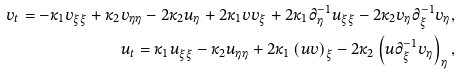<formula> <loc_0><loc_0><loc_500><loc_500>v _ { t } = - \kappa _ { 1 } v _ { \xi \xi } + \kappa _ { 2 } v _ { \eta \eta } - 2 \kappa _ { 2 } u _ { \eta } + 2 \kappa _ { 1 } v v _ { \xi } + 2 \kappa _ { 1 } \partial _ { \eta } ^ { - 1 } u _ { \xi \xi } - 2 \kappa _ { 2 } v _ { \eta } \partial _ { \xi } ^ { - 1 } v _ { \eta } , \\ u _ { t } = \kappa _ { 1 } u _ { \xi \xi } - \kappa _ { 2 } u _ { \eta \eta } + 2 \kappa _ { 1 } \left ( u v \right ) _ { \xi } - 2 \kappa _ { 2 } \left ( u \partial _ { \xi } ^ { - 1 } v _ { \eta } \right ) _ { \eta } ,</formula> 